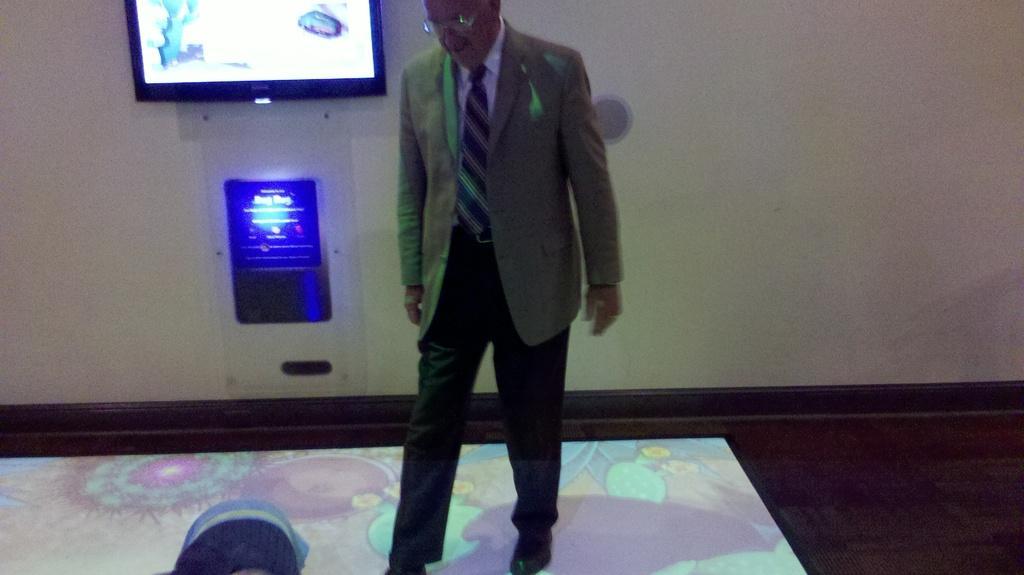In one or two sentences, can you explain what this image depicts? There is a person wearing a coat, tie and a specs. In the back there is a wall. On the wall there is a screen and a device with blue color light. 